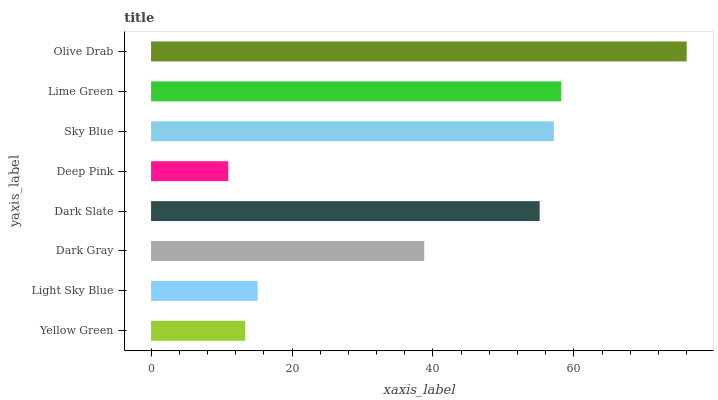Is Deep Pink the minimum?
Answer yes or no. Yes. Is Olive Drab the maximum?
Answer yes or no. Yes. Is Light Sky Blue the minimum?
Answer yes or no. No. Is Light Sky Blue the maximum?
Answer yes or no. No. Is Light Sky Blue greater than Yellow Green?
Answer yes or no. Yes. Is Yellow Green less than Light Sky Blue?
Answer yes or no. Yes. Is Yellow Green greater than Light Sky Blue?
Answer yes or no. No. Is Light Sky Blue less than Yellow Green?
Answer yes or no. No. Is Dark Slate the high median?
Answer yes or no. Yes. Is Dark Gray the low median?
Answer yes or no. Yes. Is Yellow Green the high median?
Answer yes or no. No. Is Light Sky Blue the low median?
Answer yes or no. No. 